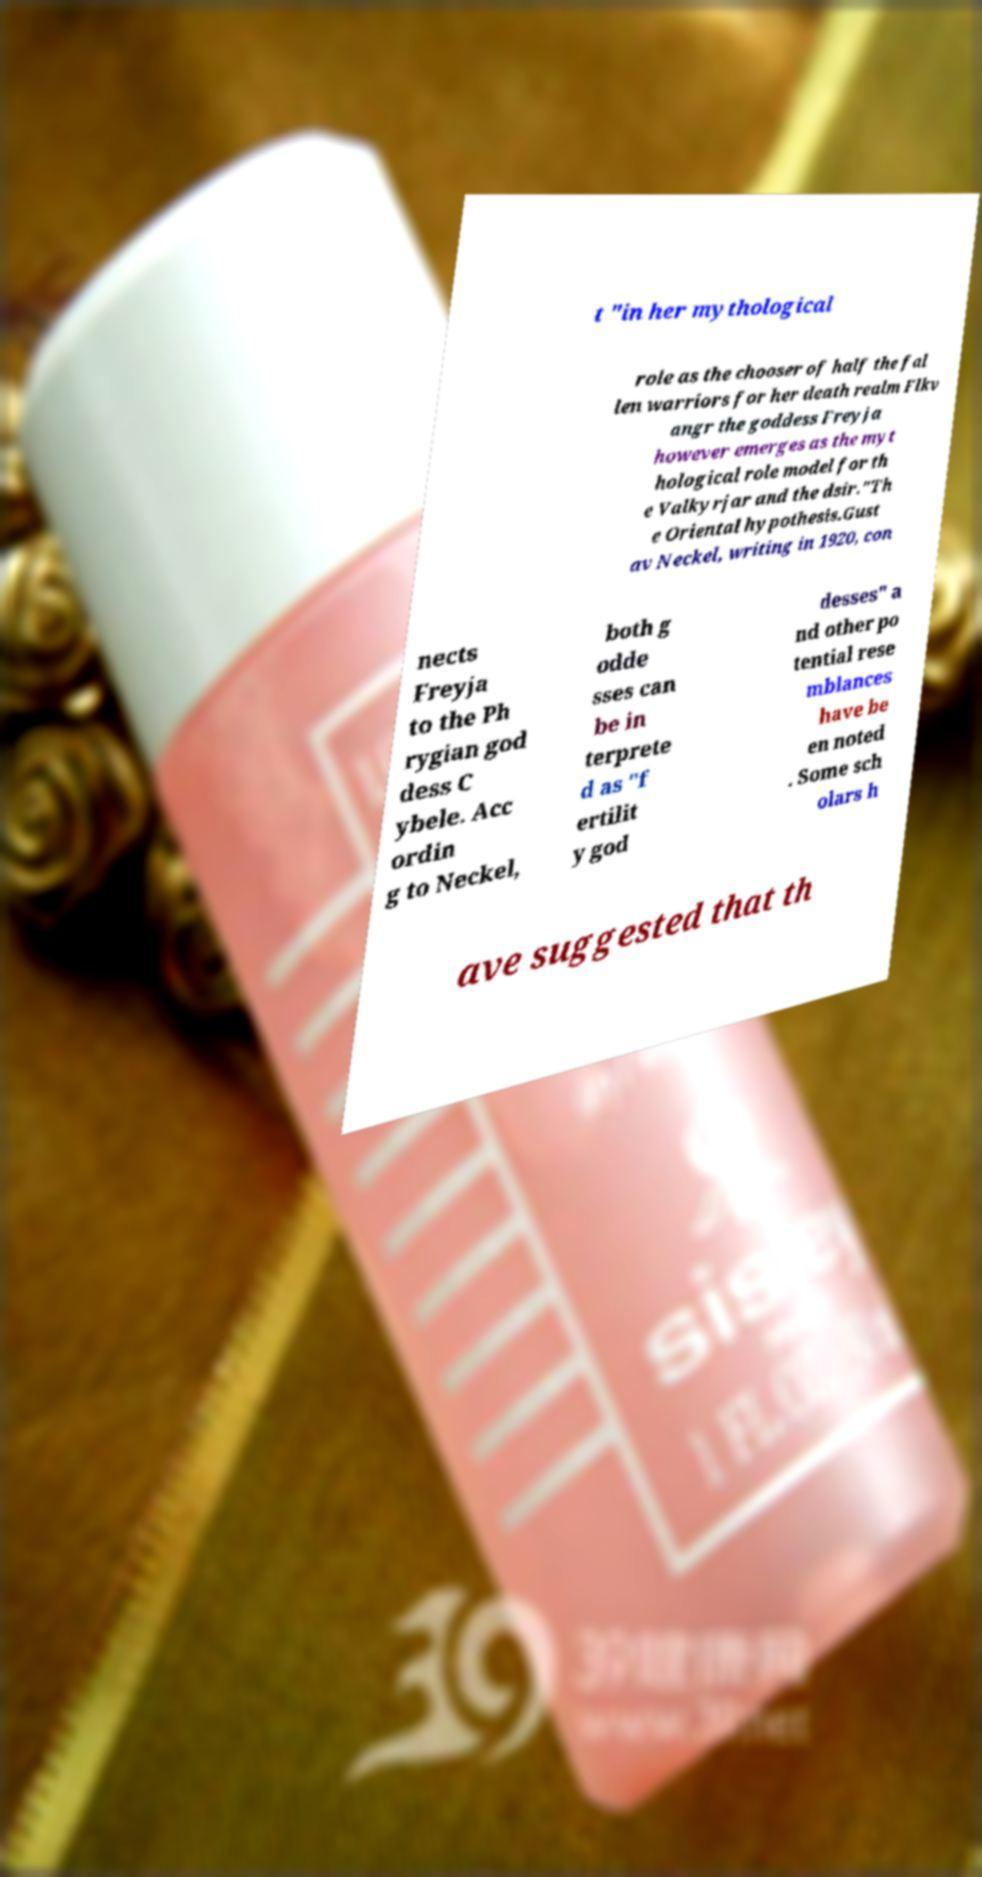Could you assist in decoding the text presented in this image and type it out clearly? t "in her mythological role as the chooser of half the fal len warriors for her death realm Flkv angr the goddess Freyja however emerges as the myt hological role model for th e Valkyrjar and the dsir."Th e Oriental hypothesis.Gust av Neckel, writing in 1920, con nects Freyja to the Ph rygian god dess C ybele. Acc ordin g to Neckel, both g odde sses can be in terprete d as "f ertilit y god desses" a nd other po tential rese mblances have be en noted . Some sch olars h ave suggested that th 